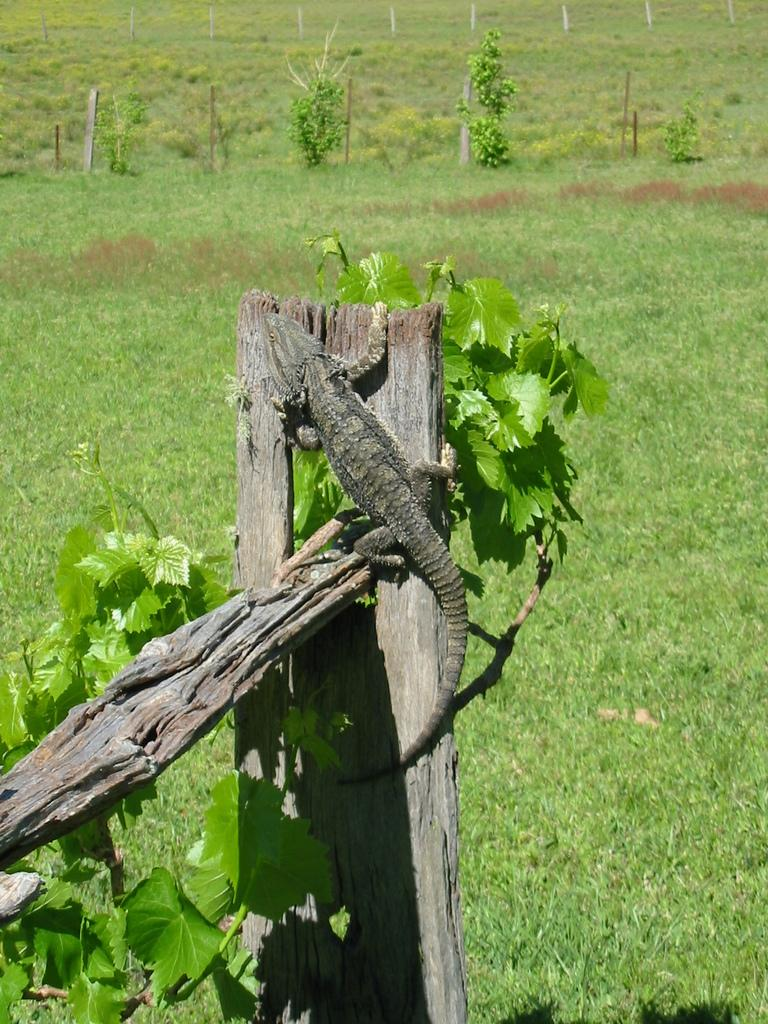What type of animal is in the image? There is a monitor lizard in the image. What is the monitor lizard resting on? The monitor lizard is on a wooden plank. What can be seen in the distance in the image? There are trees visible in the background of the image. What type of dirt is covering the monitor lizard's veil in the image? There is no dirt or veil present in the image; the monitor lizard is on a wooden plank with no visible coverings. 